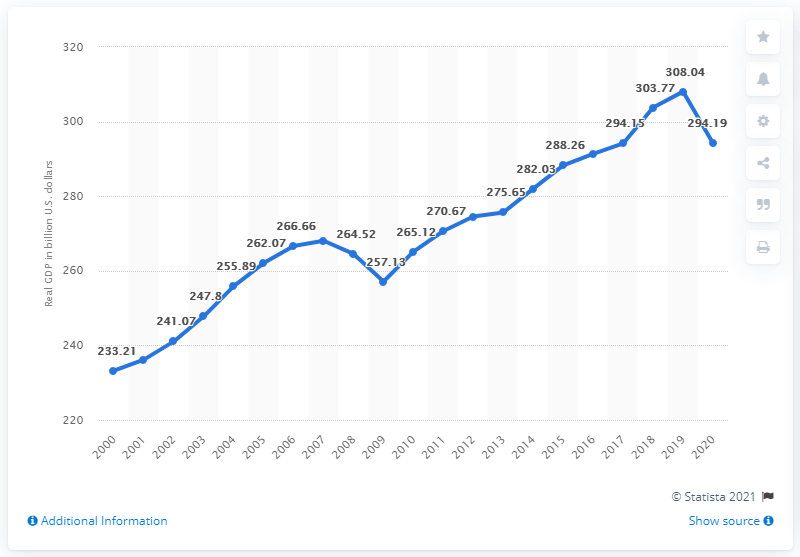Specify some key components in this picture. In 2021, Wisconsin's real GDP in dollars was 308.04. In 2020, the real Gross Domestic Product (GDP) of Wisconsin was $294.19 billion in current dollars. 